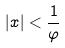Convert formula to latex. <formula><loc_0><loc_0><loc_500><loc_500>| x | < \frac { 1 } { \varphi }</formula> 